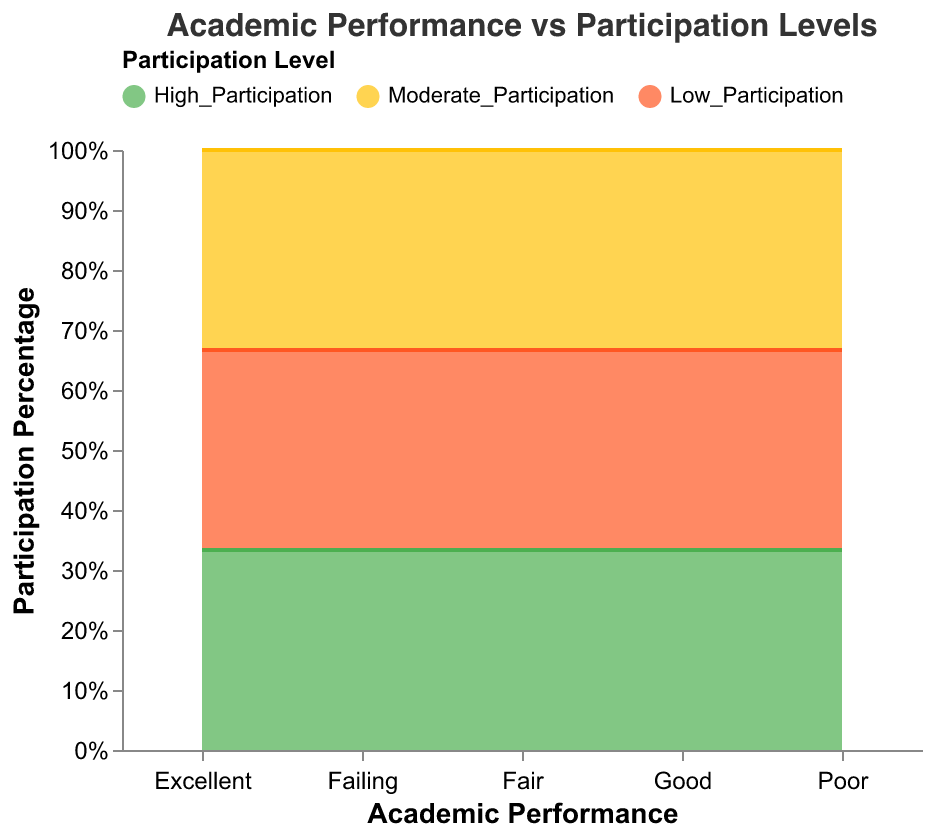What is the title of the chart? The title is displayed at the top of the chart and reads "Academic Performance vs Participation Levels," indicating what the chart is about.
Answer: Academic Performance vs Participation Levels How many different participation levels are displayed in the chart? There are three different colored sections in the stacked area that represent different participation levels, specifically High Participation, Moderate Participation, and Low Participation.
Answer: Three Which participation level color represents high participation? By observing the color legend at the top of the chart, the color representing High Participation is green (#4CAF50).
Answer: Green What is the academic performance level with the highest proportion of high participation? By looking at the stacked areas, the academic performance labeled "Good" has the largest green section, indicating the highest proportion of high participation.
Answer: Good Which academic performance level has the lowest proportion of moderate participation? By comparing the yellow areas across the performance levels, "Failing" has the thinnest yellow section, indicating the lowest proportion of moderate participation.
Answer: Failing How does moderate participation compare between "Fair" and "Good" academic performances? The yellow section (Moderate Participation) in "Fair" is larger than in "Good." By observing the stacked areas, moderate participation is higher in "Fair" than in "Good."
Answer: Fair has higher What is the sum of the proportions of high and low participation in "Poor" academic performance? The proportions are shown in the green and red sections. For "Poor" academic performance, High Participation is 10% and Low Participation is 25%. Summing these gives 35%.
Answer: 35% Which academic performance level has the smallest proportion of low participation? By observing the red areas in the stacked sections, "Excellent" has the smallest red section, indicating the lowest proportion of low participation.
Answer: Excellent What is the general trend between participation levels and academic performance? By analyzing the chart, as academic performance decreases from "Excellent" to "Failing," high participation generally decreases while low participation generally increases.
Answer: High decreases, Low increases 